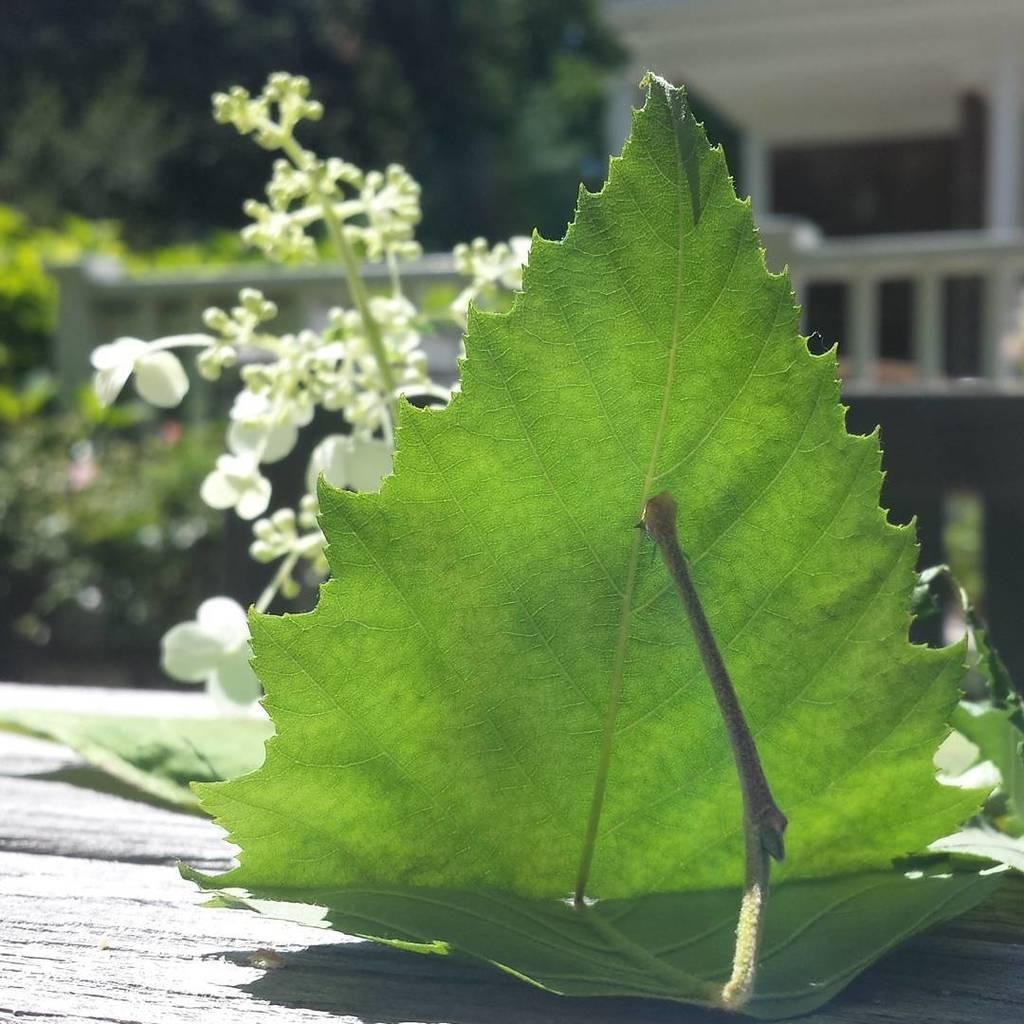What is the main subject in the center of the image? There are leaves and flowers in the center of the image. What is the color of the leaves and flowers? The leaves and flowers are white in color. What can be seen in the background of the image? There is a building, a fence, trees, and a few other objects in the background of the image. Can you describe the zephyr blowing through the leaves and flowers in the image? There is no zephyr present in the image; it is a still image of leaves and flowers. What type of straw is being used to stir the flowers in the image? There is no straw present in the image, and the flowers are not being stirred. 